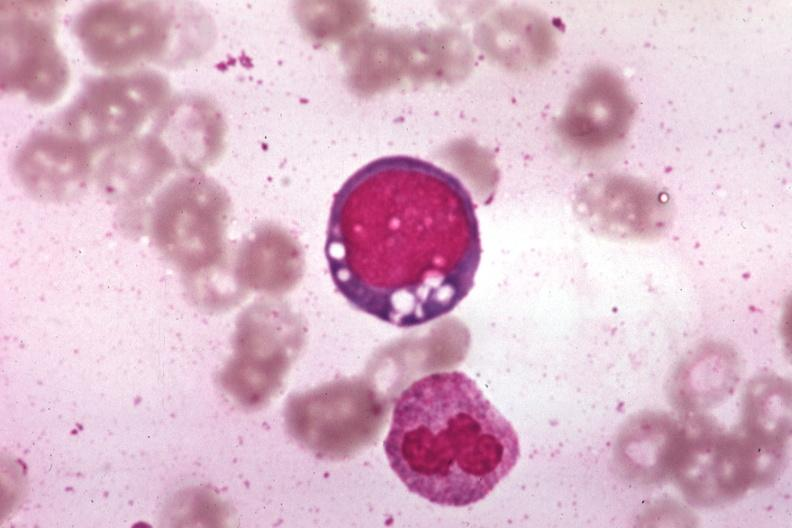does acrocyanosis show wrights vacuolated erythroblast source unknown?
Answer the question using a single word or phrase. No 